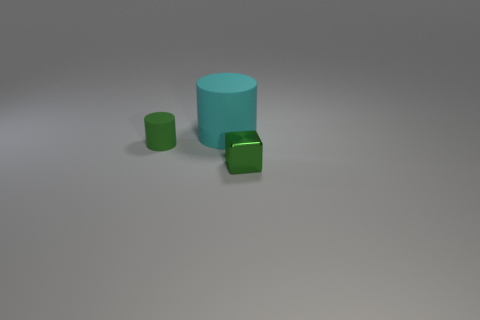What size is the green cylinder?
Offer a terse response. Small. What color is the rubber cylinder that is to the left of the rubber object on the right side of the tiny green thing left of the cyan matte object?
Your answer should be very brief. Green. There is a rubber object that is in front of the cyan thing; is its color the same as the block?
Give a very brief answer. Yes. How many tiny green things are on the left side of the large cyan rubber cylinder and on the right side of the cyan cylinder?
Your response must be concise. 0. There is a cyan thing that is the same shape as the green rubber thing; what size is it?
Give a very brief answer. Large. How many tiny metallic cubes are on the left side of the rubber object behind the small object behind the tiny block?
Give a very brief answer. 0. The matte object that is to the right of the small green object behind the green shiny cube is what color?
Your answer should be very brief. Cyan. How many other objects are the same material as the cyan object?
Your response must be concise. 1. There is a green thing behind the green metallic thing; how many small rubber objects are in front of it?
Your answer should be very brief. 0. Are there any other things that have the same shape as the large object?
Offer a terse response. Yes. 